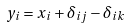Convert formula to latex. <formula><loc_0><loc_0><loc_500><loc_500>y _ { i } = x _ { i } + \delta _ { i j } - \delta _ { i k }</formula> 